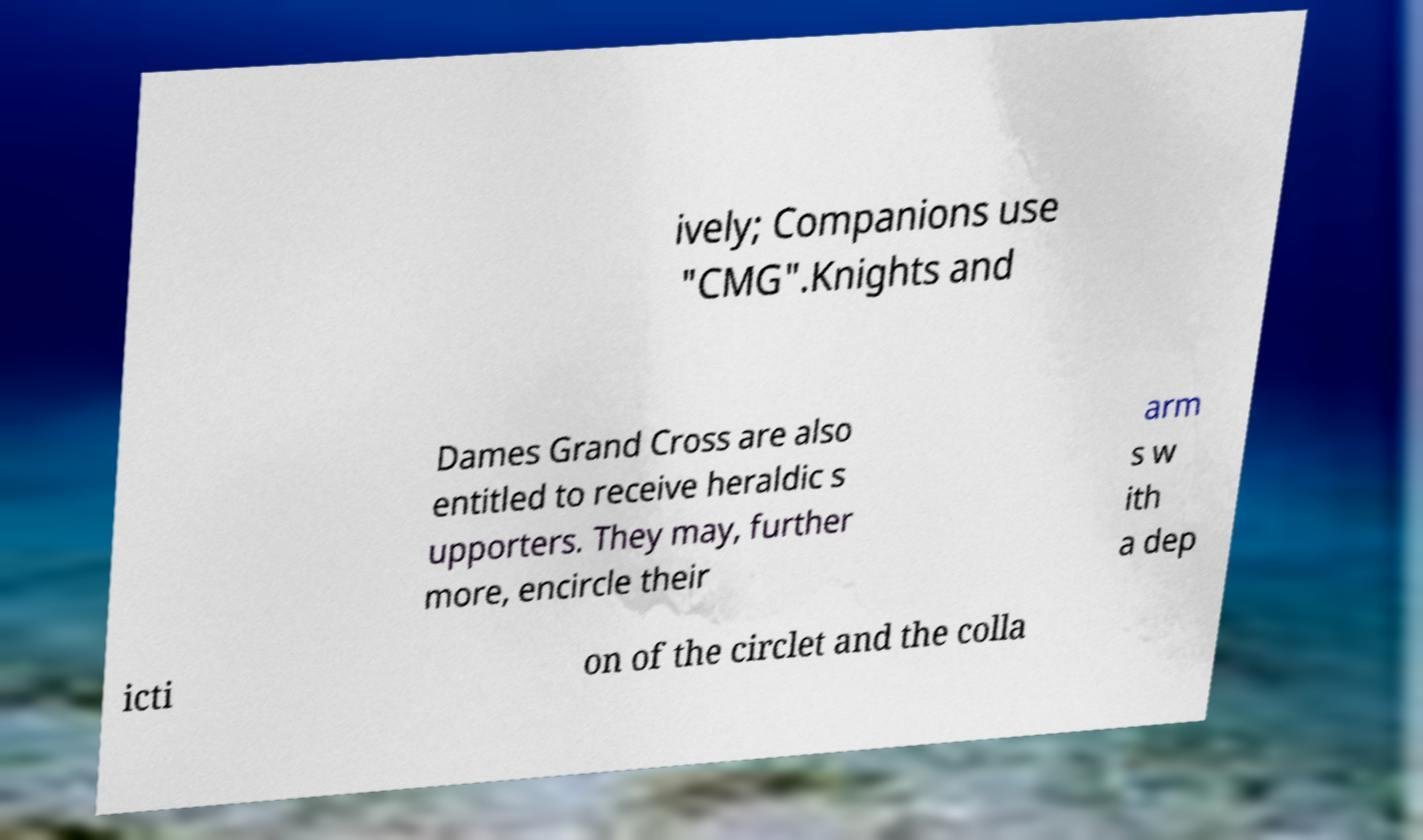Please identify and transcribe the text found in this image. ively; Companions use "CMG".Knights and Dames Grand Cross are also entitled to receive heraldic s upporters. They may, further more, encircle their arm s w ith a dep icti on of the circlet and the colla 